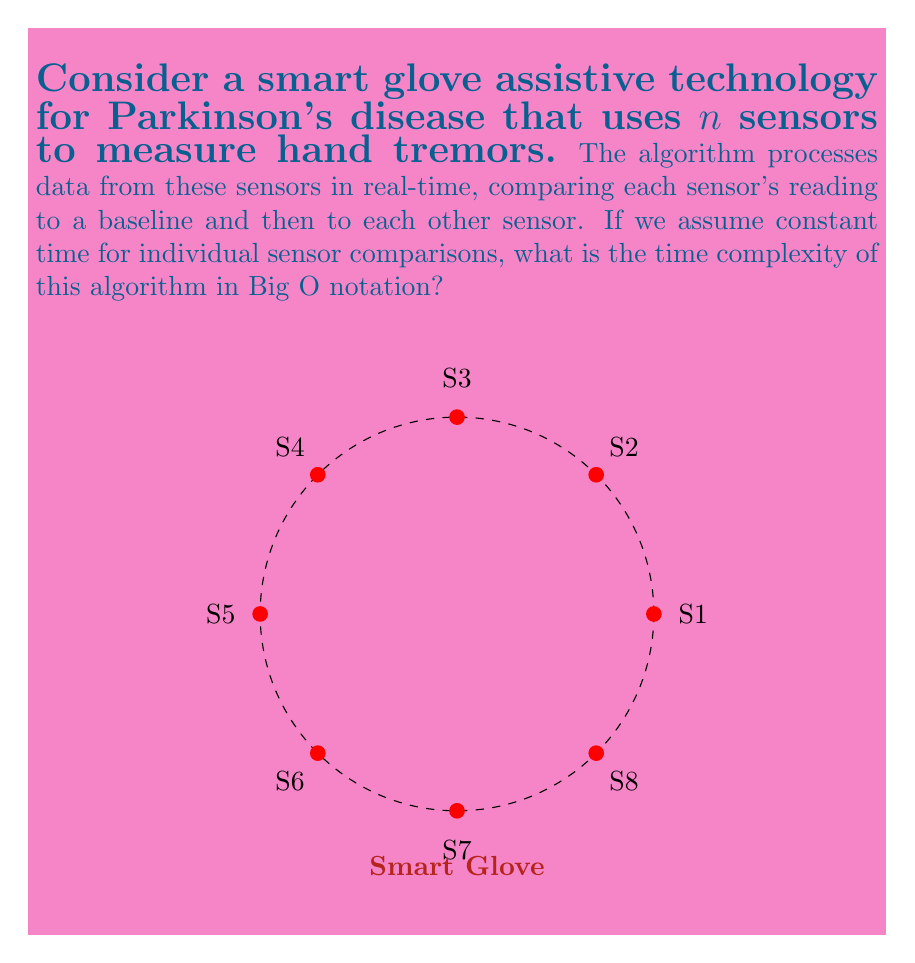Give your solution to this math problem. Let's analyze the algorithm step-by-step:

1) First, each sensor's reading is compared to a baseline:
   - This operation is performed for all $n$ sensors.
   - Time complexity: $O(n)$

2) Then, each sensor's reading is compared to every other sensor:
   - For the first sensor, it's compared to $(n-1)$ other sensors.
   - For the second sensor, it's compared to $(n-2)$ other sensors.
   - This continues until the last sensor, which isn't compared to any (as all comparisons have been made).

3) The total number of comparisons in step 2 can be represented as:
   $$(n-1) + (n-2) + (n-3) + ... + 2 + 1 = \frac{n(n-1)}{2}$$

4) This sum is derived from the arithmetic series formula: 
   $$\sum_{i=1}^{n-1} i = \frac{n(n-1)}{2}$$

5) The time complexity of step 2 is therefore $O(n^2)$

6) Combining the complexities from steps 1 and 2:
   $$O(n) + O(n^2) = O(n^2)$$

7) As $n^2$ grows faster than $n$ for large $n$, the overall time complexity is dominated by the $O(n^2)$ term.

Therefore, the time complexity of this algorithm is $O(n^2)$.
Answer: $O(n^2)$ 